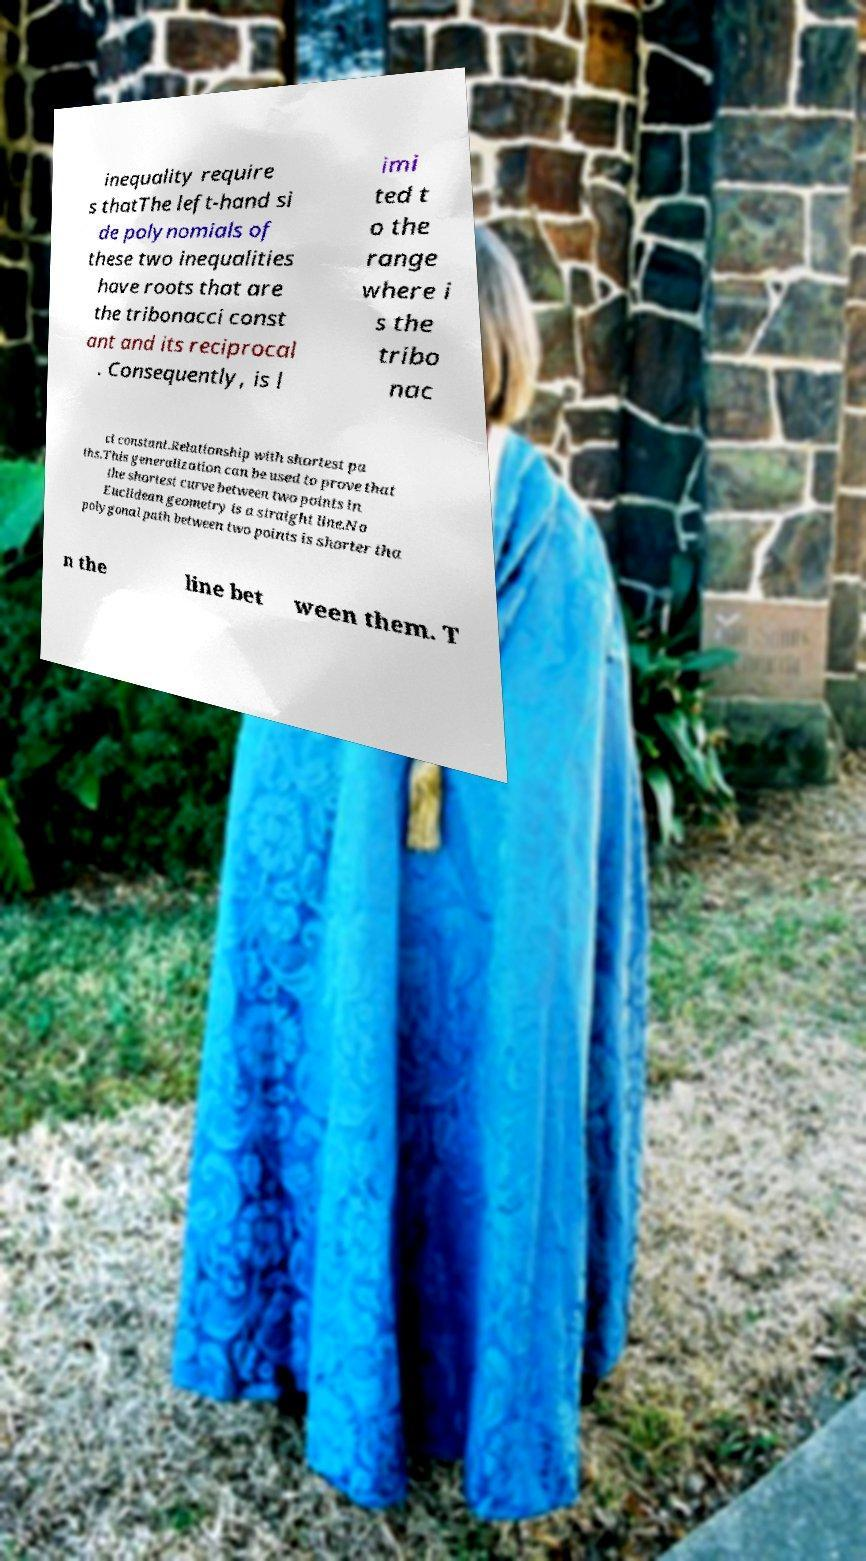Can you accurately transcribe the text from the provided image for me? inequality require s thatThe left-hand si de polynomials of these two inequalities have roots that are the tribonacci const ant and its reciprocal . Consequently, is l imi ted t o the range where i s the tribo nac ci constant.Relationship with shortest pa ths.This generalization can be used to prove that the shortest curve between two points in Euclidean geometry is a straight line.No polygonal path between two points is shorter tha n the line bet ween them. T 